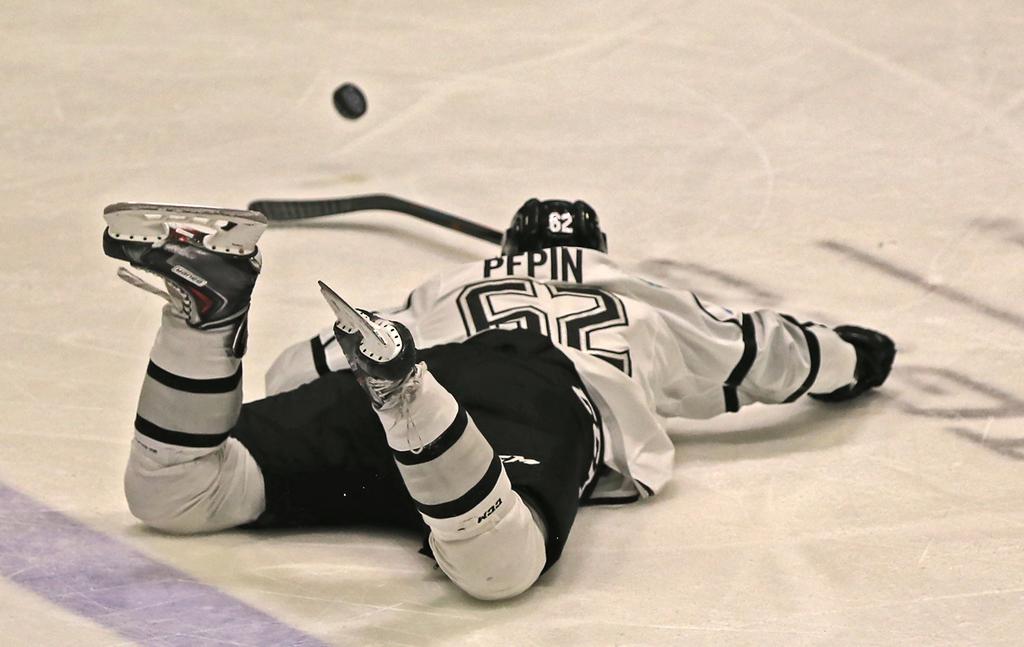What is the player's last name?
Offer a terse response. Pepin. What is the number for pepin?
Offer a terse response. 62. 